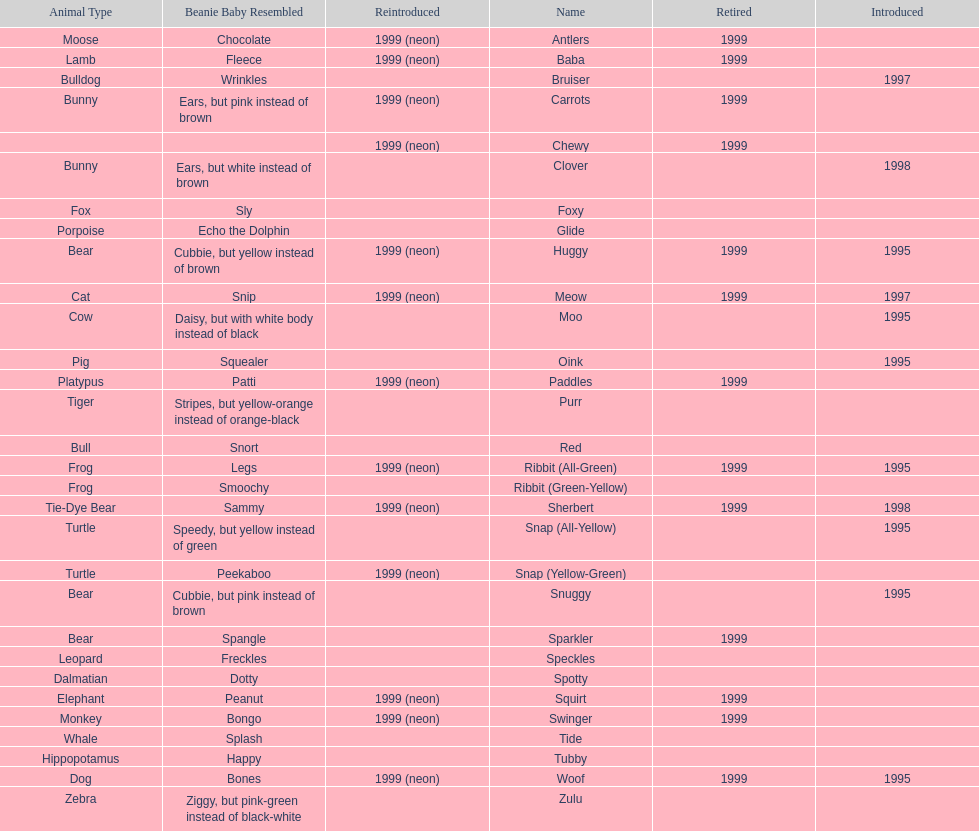How long was woof the dog sold before it was retired? 4 years. 